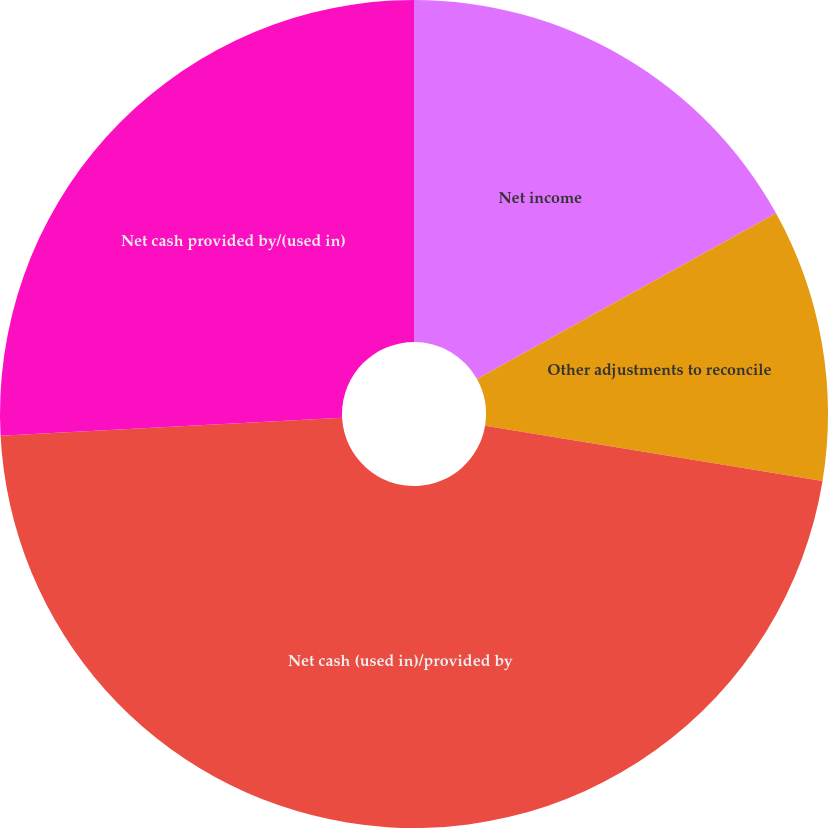Convert chart to OTSL. <chart><loc_0><loc_0><loc_500><loc_500><pie_chart><fcel>Net income<fcel>Other adjustments to reconcile<fcel>Net cash (used in)/provided by<fcel>Net cash provided by/(used in)<nl><fcel>16.94%<fcel>10.65%<fcel>46.57%<fcel>25.84%<nl></chart> 